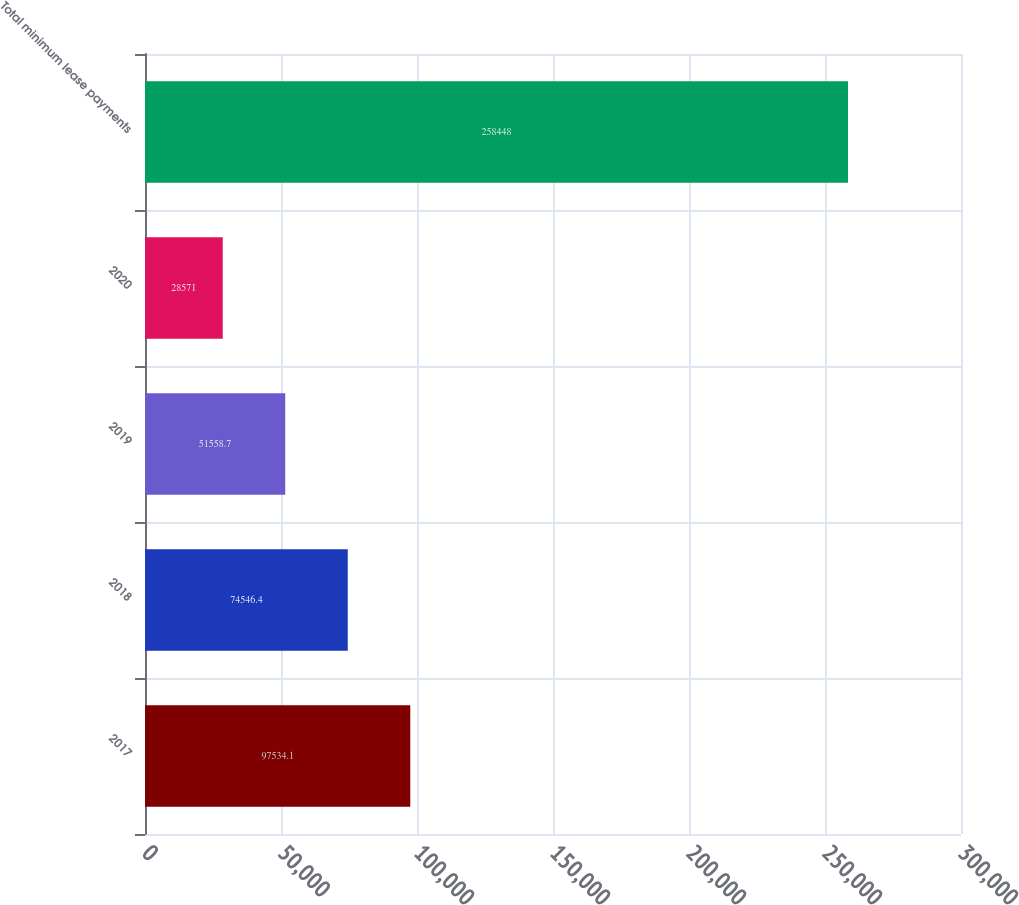Convert chart. <chart><loc_0><loc_0><loc_500><loc_500><bar_chart><fcel>2017<fcel>2018<fcel>2019<fcel>2020<fcel>Total minimum lease payments<nl><fcel>97534.1<fcel>74546.4<fcel>51558.7<fcel>28571<fcel>258448<nl></chart> 